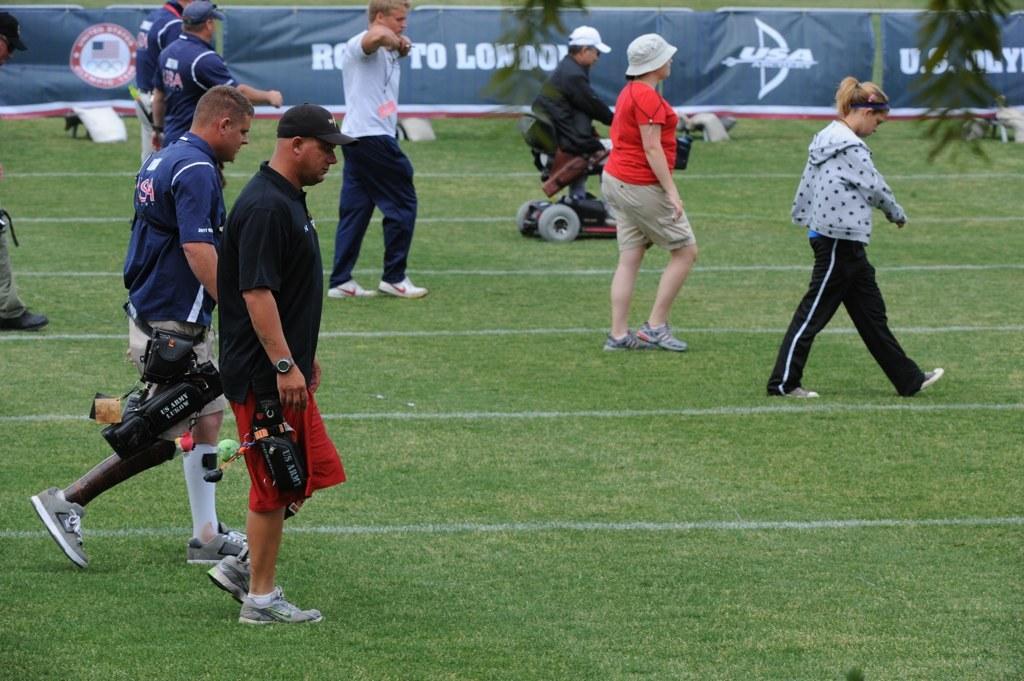What is the ad begin displayed in the background?
Give a very brief answer. Usa. 